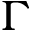Convert formula to latex. <formula><loc_0><loc_0><loc_500><loc_500>\Gamma</formula> 